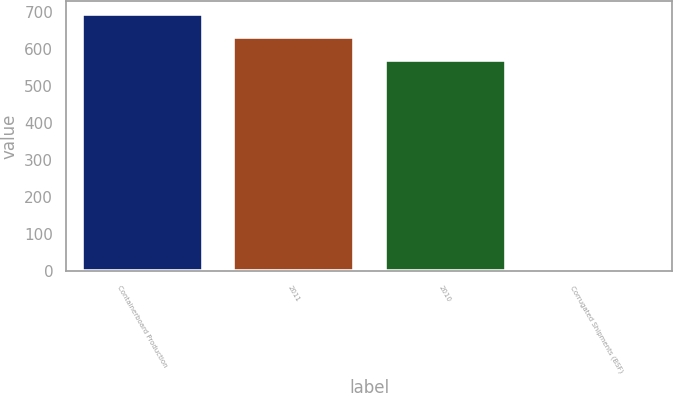Convert chart. <chart><loc_0><loc_0><loc_500><loc_500><bar_chart><fcel>Containerboard Production<fcel>2011<fcel>2010<fcel>Corrugated Shipments (BSF)<nl><fcel>695.3<fcel>632.15<fcel>569<fcel>8.5<nl></chart> 